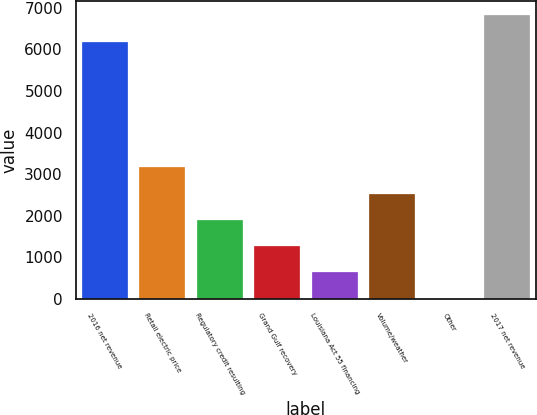Convert chart to OTSL. <chart><loc_0><loc_0><loc_500><loc_500><bar_chart><fcel>2016 net revenue<fcel>Retail electric price<fcel>Regulatory credit resulting<fcel>Grand Gulf recovery<fcel>Louisiana Act 55 financing<fcel>Volume/weather<fcel>Other<fcel>2017 net revenue<nl><fcel>6179<fcel>3163.5<fcel>1901.7<fcel>1270.8<fcel>639.9<fcel>2532.6<fcel>9<fcel>6809.9<nl></chart> 